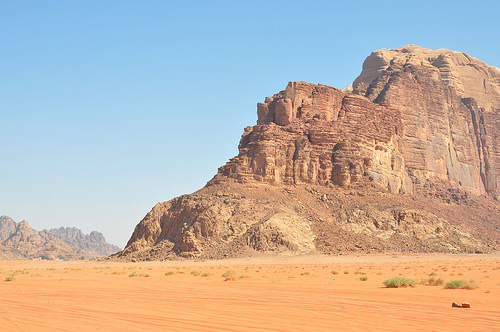<image>
Can you confirm if the big cliff is behind the small cliff? No. The big cliff is not behind the small cliff. From this viewpoint, the big cliff appears to be positioned elsewhere in the scene. Where is the granite hill in relation to the desert area? Is it above the desert area? Yes. The granite hill is positioned above the desert area in the vertical space, higher up in the scene. 